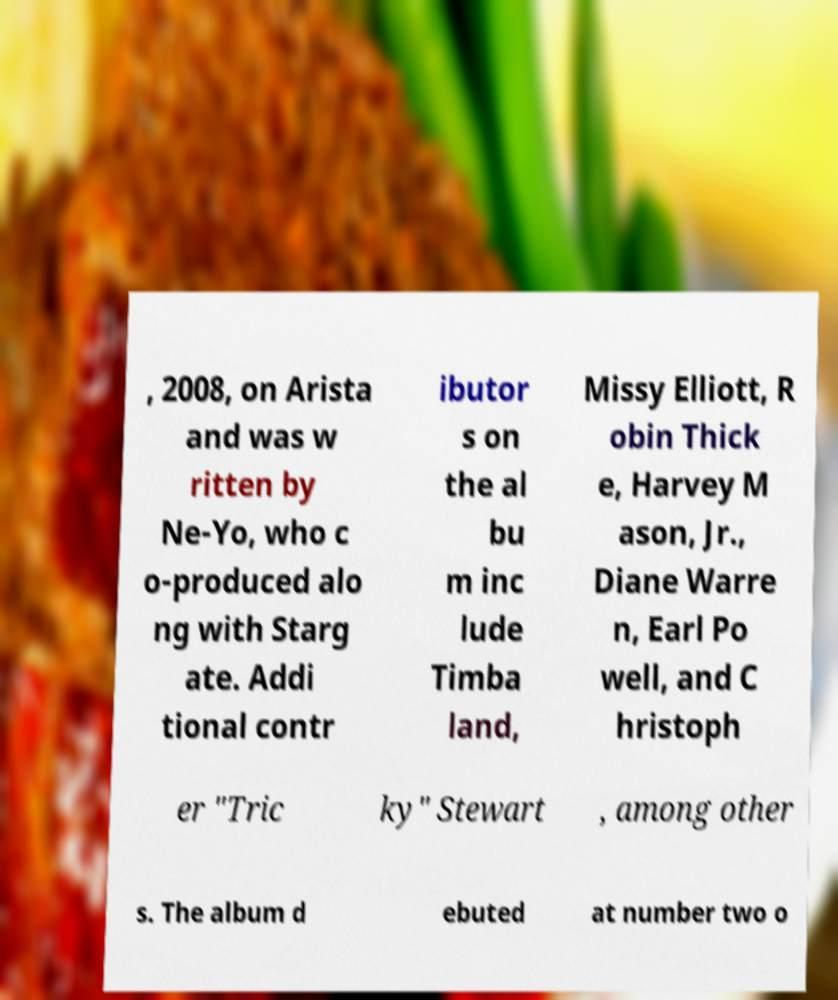Could you assist in decoding the text presented in this image and type it out clearly? , 2008, on Arista and was w ritten by Ne-Yo, who c o-produced alo ng with Starg ate. Addi tional contr ibutor s on the al bu m inc lude Timba land, Missy Elliott, R obin Thick e, Harvey M ason, Jr., Diane Warre n, Earl Po well, and C hristoph er "Tric ky" Stewart , among other s. The album d ebuted at number two o 